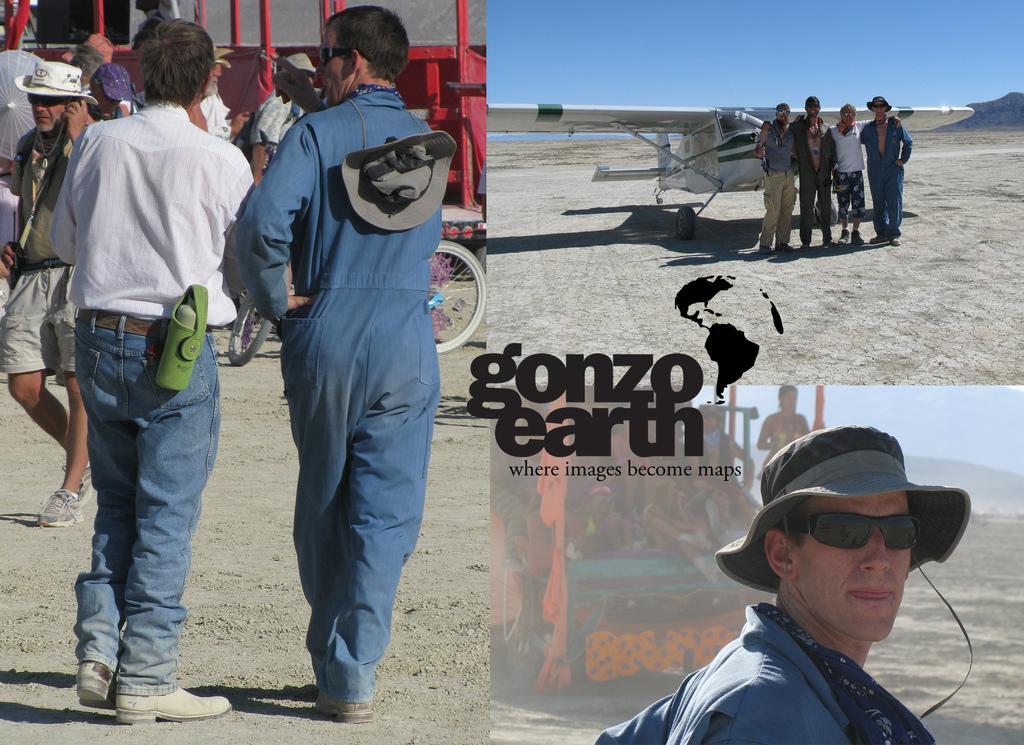Please provide a concise description of this image. On the left side of the image we can see people standing on the sand, carts and a bicycle. In the top right hand corner of the image we can see people standing on the sand in front of the aeroplane, sky and hills. In the bottom right hand corner of the image we can see a man, people sitting on the motor vehicle, hills and sky. 